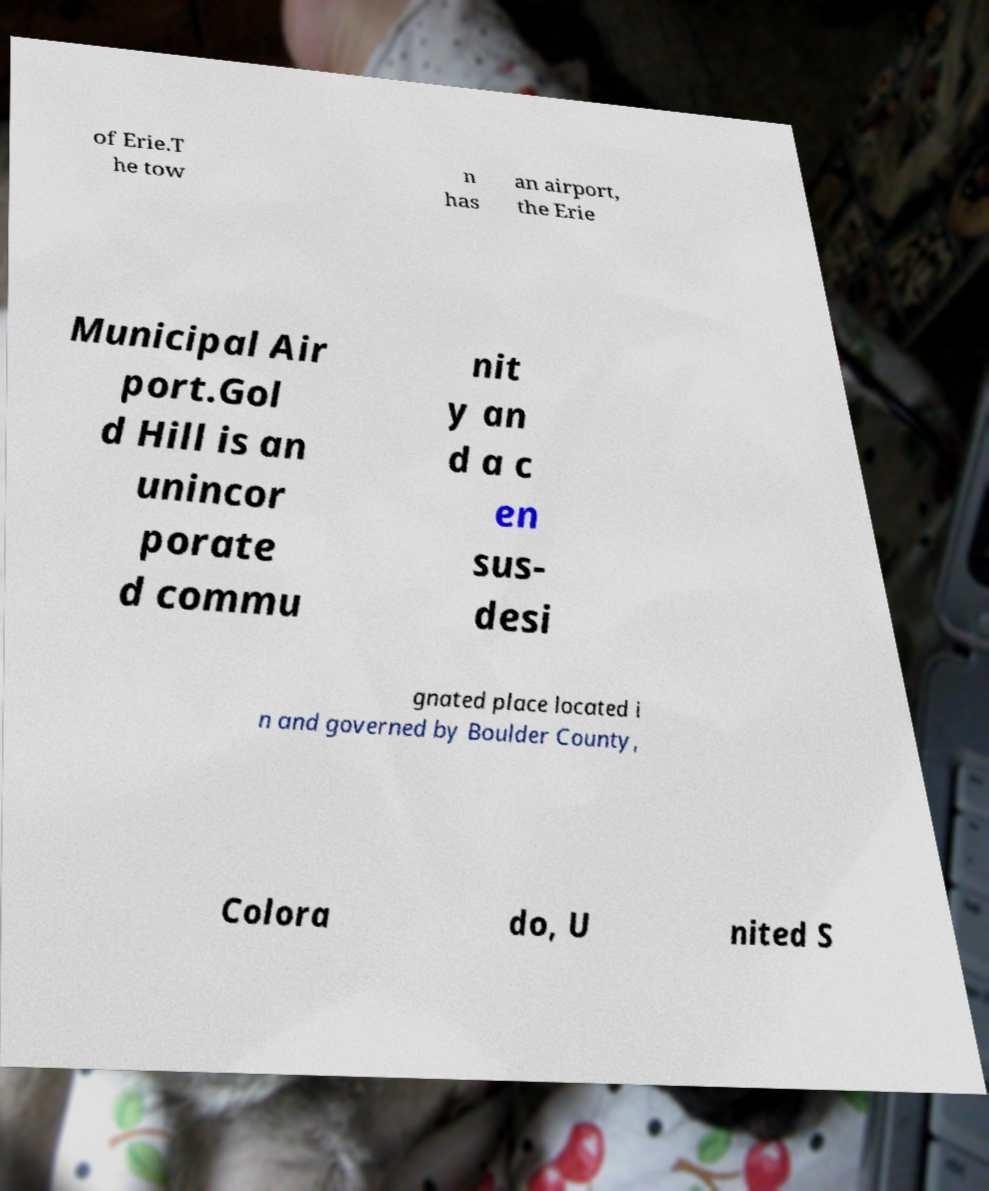For documentation purposes, I need the text within this image transcribed. Could you provide that? of Erie.T he tow n has an airport, the Erie Municipal Air port.Gol d Hill is an unincor porate d commu nit y an d a c en sus- desi gnated place located i n and governed by Boulder County, Colora do, U nited S 